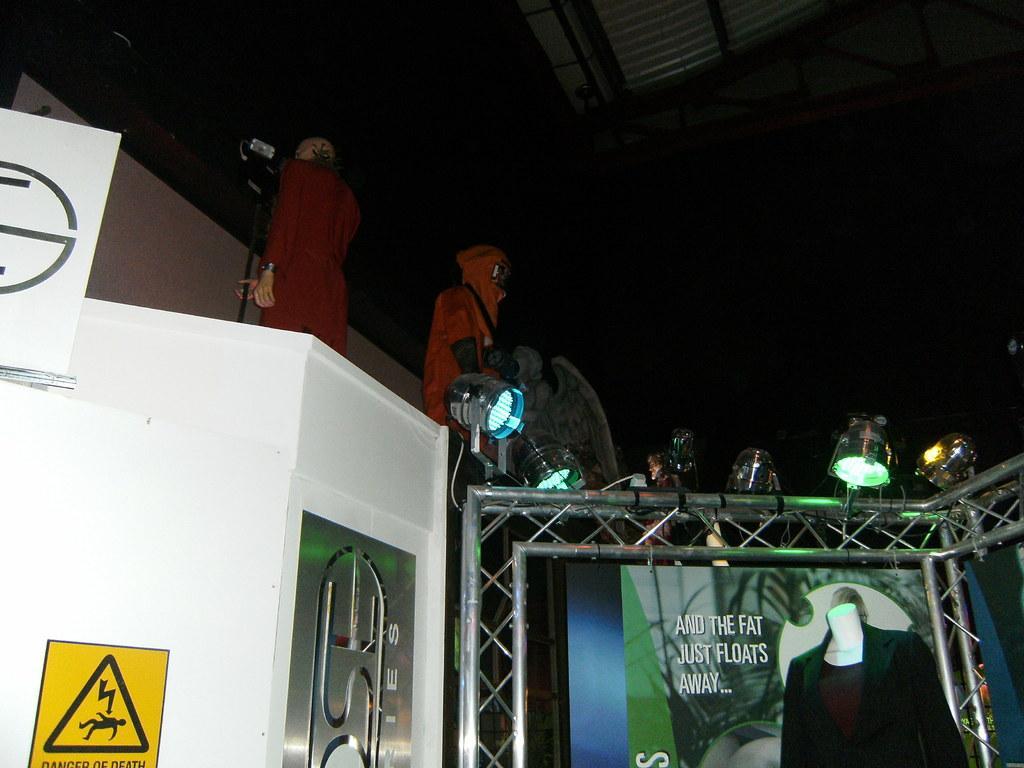Describe this image in one or two sentences. In the image we can see there are people wearing clothes, they are standing. This is a poster, lights and a board. 